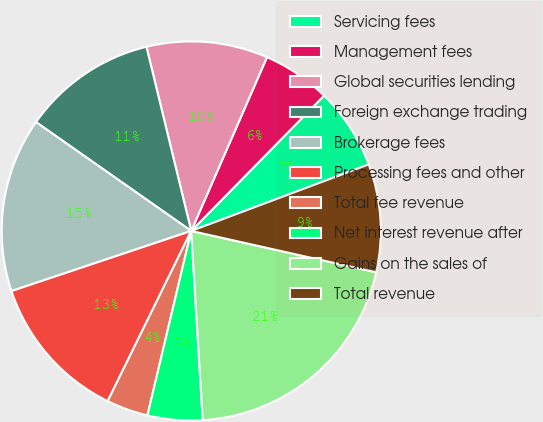Convert chart to OTSL. <chart><loc_0><loc_0><loc_500><loc_500><pie_chart><fcel>Servicing fees<fcel>Management fees<fcel>Global securities lending<fcel>Foreign exchange trading<fcel>Brokerage fees<fcel>Processing fees and other<fcel>Total fee revenue<fcel>Net interest revenue after<fcel>Gains on the sales of<fcel>Total revenue<nl><fcel>6.94%<fcel>5.81%<fcel>10.34%<fcel>11.47%<fcel>14.87%<fcel>12.6%<fcel>3.55%<fcel>4.68%<fcel>20.53%<fcel>9.21%<nl></chart> 